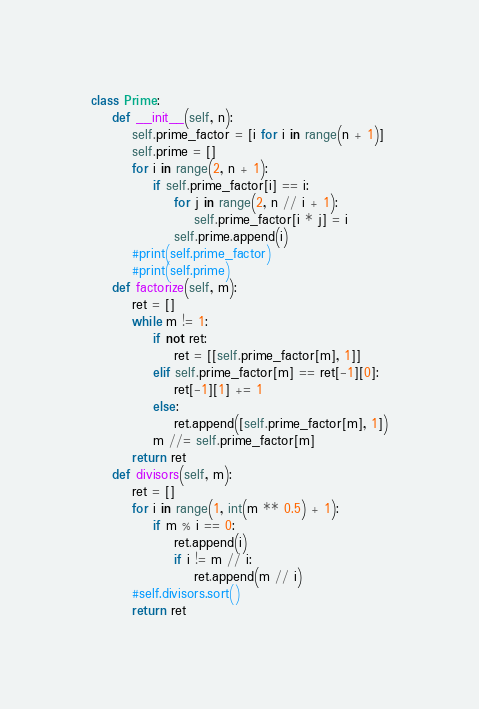<code> <loc_0><loc_0><loc_500><loc_500><_Python_>class Prime:
    def __init__(self, n):
        self.prime_factor = [i for i in range(n + 1)]
        self.prime = []
        for i in range(2, n + 1):
            if self.prime_factor[i] == i:
                for j in range(2, n // i + 1):
                    self.prime_factor[i * j] = i
                self.prime.append(i)
        #print(self.prime_factor)
        #print(self.prime)
    def factorize(self, m):
        ret = []
        while m != 1:
            if not ret:
                ret = [[self.prime_factor[m], 1]]
            elif self.prime_factor[m] == ret[-1][0]:
                ret[-1][1] += 1
            else:
                ret.append([self.prime_factor[m], 1])
            m //= self.prime_factor[m]
        return ret
    def divisors(self, m):
        ret = []
        for i in range(1, int(m ** 0.5) + 1):
            if m % i == 0:
                ret.append(i)
                if i != m // i:
                    ret.append(m // i)
        #self.divisors.sort()
        return ret</code> 